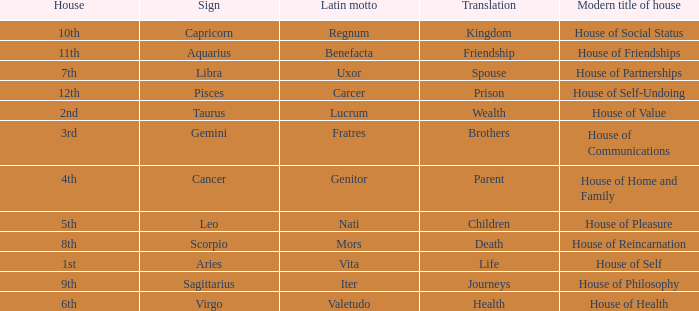Which modern house title translates to prison? House of Self-Undoing. 